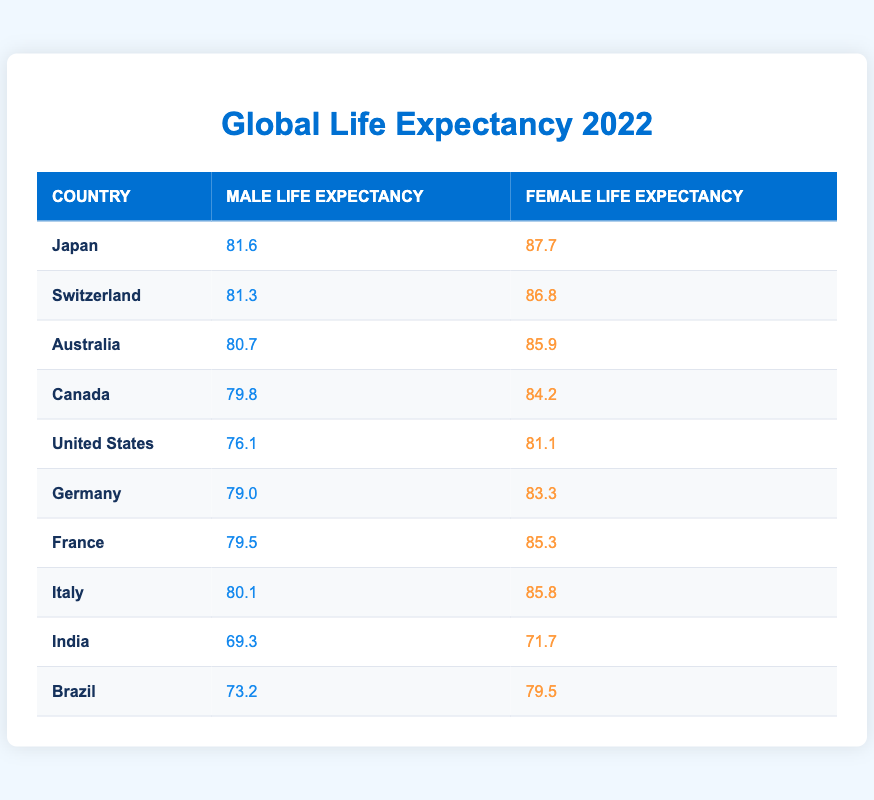What is the average life expectancy for males in Japan? The table shows that the average life expectancy for males in Japan is listed as 81.6.
Answer: 81.6 What country has the highest average female life expectancy? From the table, Japan has the highest average female life expectancy of 87.7.
Answer: Japan Which country has a lower life expectancy for males than the United States? The table indicates that both Canada (79.8) and Germany (79.0) have male life expectancy values lower than that of the United States (76.1).
Answer: Canada and Germany What is the difference between the average life expectancy of males and females in Brazil? In Brazil, the average life expectancy for males is 73.2 and for females is 79.5. The difference is calculated as 79.5 - 73.2 = 6.3.
Answer: 6.3 Is the average life expectancy for males in Germany higher than that of Brazil? According to the table, Germany has an average male life expectancy of 79.0, while Brazil's is 73.2. Hence, the statement is true.
Answer: Yes What is the overall average life expectancy for males from the countries listed? To find the overall average, we sum the male life expectancies: (81.6 + 81.3 + 80.7 + 79.8 + 76.1 + 79.0 + 79.5 + 80.1 + 69.3 + 73.2) = 801.6. There are 10 entries, so the average is 801.6/10 = 80.16.
Answer: 80.16 Which country has the closest average life expectancy for males compared to Italy? Italy has an average life expectancy of 80.1 for males. Switzerland has 81.3, which is only 1.2 years higher, making it the closest comparison.
Answer: Switzerland What is the average female life expectancy across all the countries listed? To find the average female life expectancy, we sum the female life expectancies: (87.7 + 86.8 + 85.9 + 84.2 + 81.1 + 83.3 + 85.3 + 85.8 + 71.7 + 79.5) = 834.3. Dividing by 10 gives an average of 83.43.
Answer: 83.43 